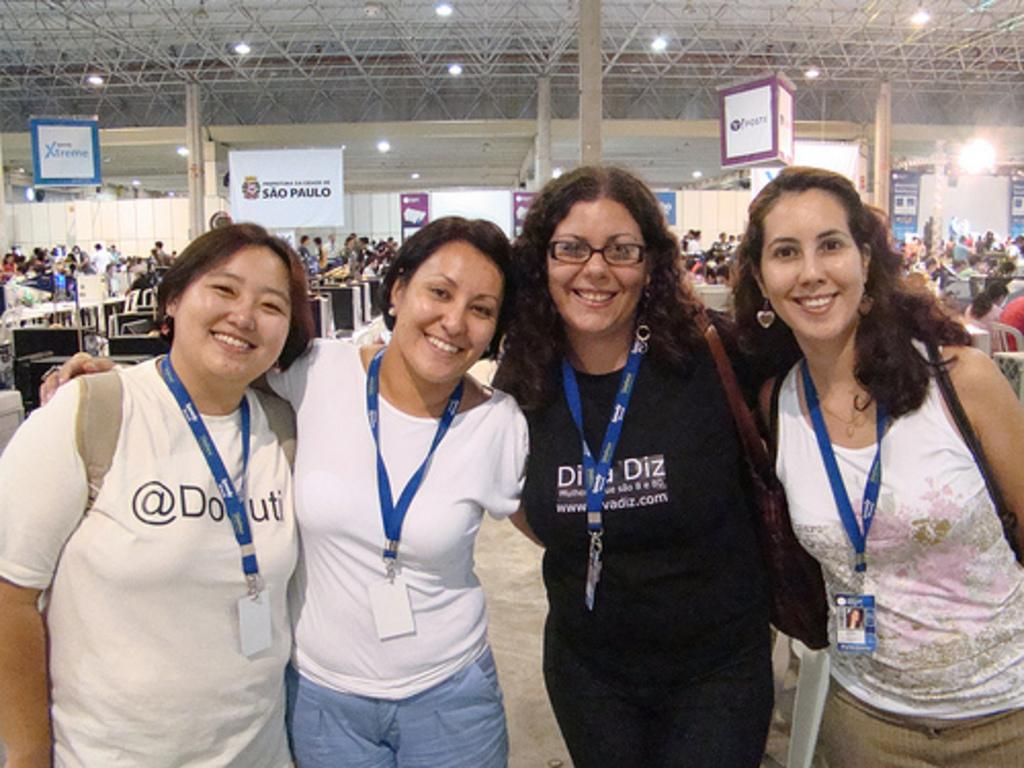<image>
Create a compact narrative representing the image presented. Four ladies posing with a sign that says Sao Paulo in the background. 